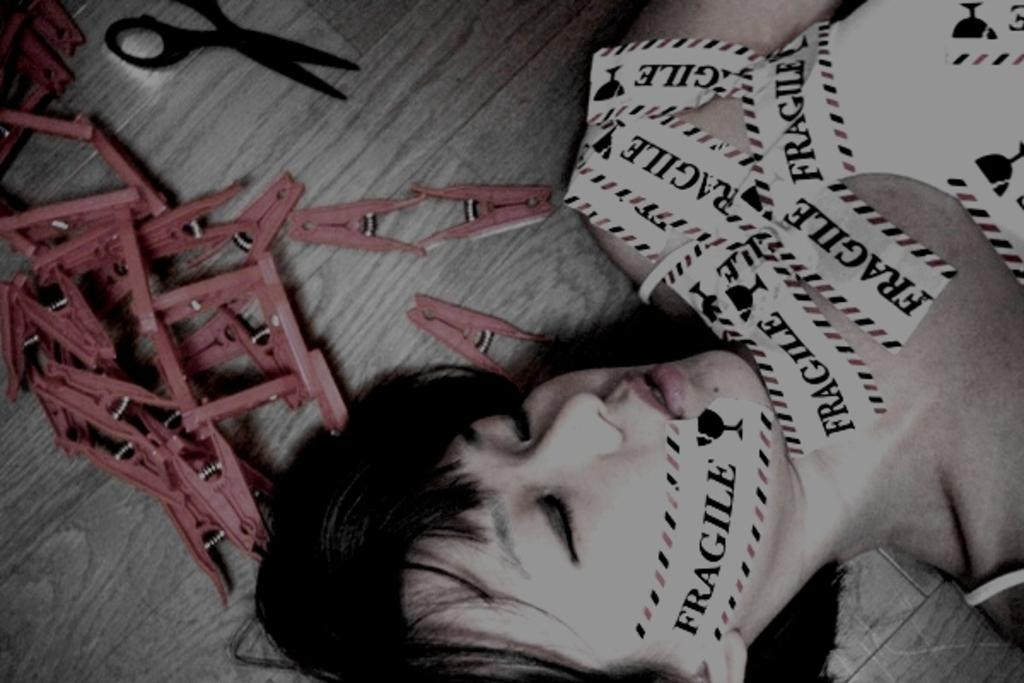Who is present in the image? There is a woman in the image. What is the woman doing in the image? The woman is lying on the floor and covering her body with papers. What object can be seen in the image that is typically used for cutting? There is a scissor in the image. What items are present in the image that are used for holding or organizing cloth? There are cloth holders in the image. What type of nail can be seen in the image? There is no nail present in the image. Can you describe the sidewalk in the image? There is no sidewalk present in the image. 